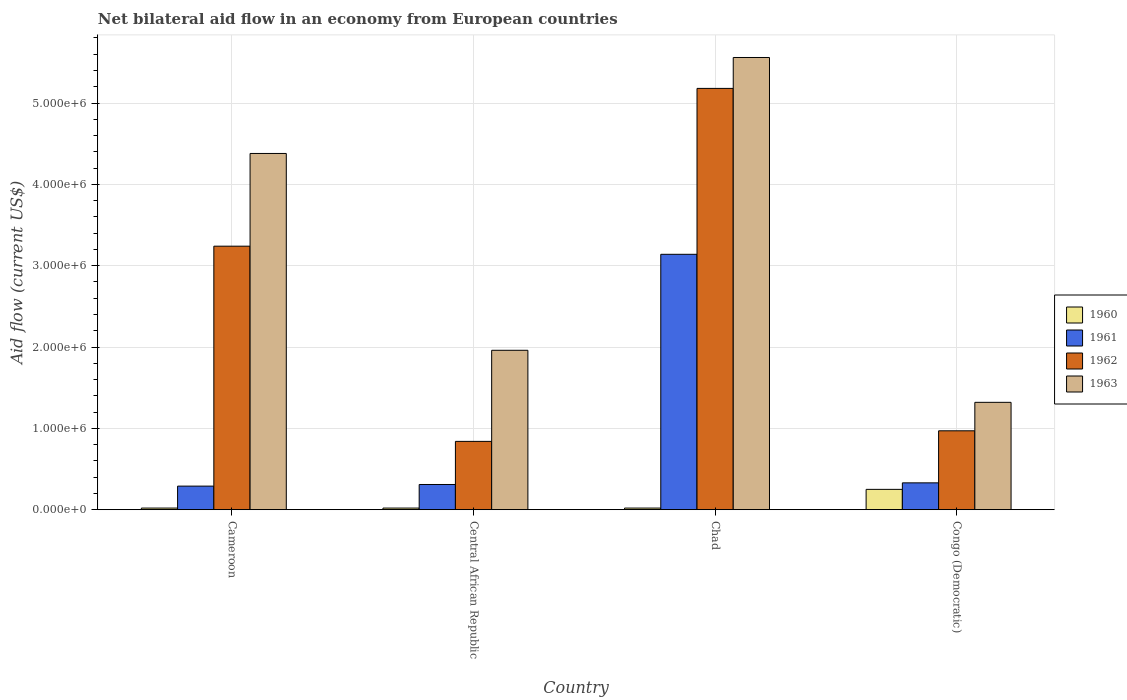How many different coloured bars are there?
Provide a succinct answer. 4. Are the number of bars per tick equal to the number of legend labels?
Give a very brief answer. Yes. How many bars are there on the 2nd tick from the left?
Your response must be concise. 4. How many bars are there on the 4th tick from the right?
Your response must be concise. 4. What is the label of the 4th group of bars from the left?
Your response must be concise. Congo (Democratic). In how many cases, is the number of bars for a given country not equal to the number of legend labels?
Ensure brevity in your answer.  0. Across all countries, what is the maximum net bilateral aid flow in 1961?
Your response must be concise. 3.14e+06. In which country was the net bilateral aid flow in 1963 maximum?
Your answer should be compact. Chad. In which country was the net bilateral aid flow in 1961 minimum?
Offer a terse response. Cameroon. What is the total net bilateral aid flow in 1961 in the graph?
Ensure brevity in your answer.  4.07e+06. What is the difference between the net bilateral aid flow in 1963 in Congo (Democratic) and the net bilateral aid flow in 1960 in Cameroon?
Your answer should be compact. 1.30e+06. What is the average net bilateral aid flow in 1961 per country?
Give a very brief answer. 1.02e+06. What is the difference between the net bilateral aid flow of/in 1962 and net bilateral aid flow of/in 1960 in Congo (Democratic)?
Provide a succinct answer. 7.20e+05. What is the ratio of the net bilateral aid flow in 1960 in Central African Republic to that in Congo (Democratic)?
Offer a terse response. 0.08. Is the difference between the net bilateral aid flow in 1962 in Cameroon and Chad greater than the difference between the net bilateral aid flow in 1960 in Cameroon and Chad?
Ensure brevity in your answer.  No. What is the difference between the highest and the second highest net bilateral aid flow in 1963?
Offer a terse response. 3.60e+06. What is the difference between the highest and the lowest net bilateral aid flow in 1961?
Offer a very short reply. 2.85e+06. In how many countries, is the net bilateral aid flow in 1963 greater than the average net bilateral aid flow in 1963 taken over all countries?
Provide a short and direct response. 2. What does the 3rd bar from the left in Central African Republic represents?
Your answer should be very brief. 1962. What does the 3rd bar from the right in Chad represents?
Provide a short and direct response. 1961. Is it the case that in every country, the sum of the net bilateral aid flow in 1963 and net bilateral aid flow in 1960 is greater than the net bilateral aid flow in 1962?
Make the answer very short. Yes. How many bars are there?
Give a very brief answer. 16. Are all the bars in the graph horizontal?
Your answer should be very brief. No. How many countries are there in the graph?
Offer a terse response. 4. Are the values on the major ticks of Y-axis written in scientific E-notation?
Ensure brevity in your answer.  Yes. Does the graph contain any zero values?
Make the answer very short. No. Where does the legend appear in the graph?
Your answer should be compact. Center right. How many legend labels are there?
Offer a very short reply. 4. What is the title of the graph?
Ensure brevity in your answer.  Net bilateral aid flow in an economy from European countries. What is the label or title of the X-axis?
Give a very brief answer. Country. What is the Aid flow (current US$) in 1962 in Cameroon?
Give a very brief answer. 3.24e+06. What is the Aid flow (current US$) of 1963 in Cameroon?
Your answer should be compact. 4.38e+06. What is the Aid flow (current US$) of 1960 in Central African Republic?
Your answer should be very brief. 2.00e+04. What is the Aid flow (current US$) of 1962 in Central African Republic?
Make the answer very short. 8.40e+05. What is the Aid flow (current US$) of 1963 in Central African Republic?
Your answer should be very brief. 1.96e+06. What is the Aid flow (current US$) in 1960 in Chad?
Keep it short and to the point. 2.00e+04. What is the Aid flow (current US$) of 1961 in Chad?
Your answer should be compact. 3.14e+06. What is the Aid flow (current US$) in 1962 in Chad?
Make the answer very short. 5.18e+06. What is the Aid flow (current US$) in 1963 in Chad?
Keep it short and to the point. 5.56e+06. What is the Aid flow (current US$) of 1962 in Congo (Democratic)?
Ensure brevity in your answer.  9.70e+05. What is the Aid flow (current US$) of 1963 in Congo (Democratic)?
Keep it short and to the point. 1.32e+06. Across all countries, what is the maximum Aid flow (current US$) in 1960?
Provide a succinct answer. 2.50e+05. Across all countries, what is the maximum Aid flow (current US$) in 1961?
Provide a succinct answer. 3.14e+06. Across all countries, what is the maximum Aid flow (current US$) of 1962?
Provide a short and direct response. 5.18e+06. Across all countries, what is the maximum Aid flow (current US$) in 1963?
Provide a succinct answer. 5.56e+06. Across all countries, what is the minimum Aid flow (current US$) in 1962?
Your response must be concise. 8.40e+05. Across all countries, what is the minimum Aid flow (current US$) of 1963?
Give a very brief answer. 1.32e+06. What is the total Aid flow (current US$) of 1961 in the graph?
Ensure brevity in your answer.  4.07e+06. What is the total Aid flow (current US$) in 1962 in the graph?
Your answer should be very brief. 1.02e+07. What is the total Aid flow (current US$) in 1963 in the graph?
Offer a very short reply. 1.32e+07. What is the difference between the Aid flow (current US$) of 1960 in Cameroon and that in Central African Republic?
Your answer should be very brief. 0. What is the difference between the Aid flow (current US$) in 1961 in Cameroon and that in Central African Republic?
Your response must be concise. -2.00e+04. What is the difference between the Aid flow (current US$) of 1962 in Cameroon and that in Central African Republic?
Provide a short and direct response. 2.40e+06. What is the difference between the Aid flow (current US$) in 1963 in Cameroon and that in Central African Republic?
Your response must be concise. 2.42e+06. What is the difference between the Aid flow (current US$) in 1960 in Cameroon and that in Chad?
Give a very brief answer. 0. What is the difference between the Aid flow (current US$) in 1961 in Cameroon and that in Chad?
Your response must be concise. -2.85e+06. What is the difference between the Aid flow (current US$) in 1962 in Cameroon and that in Chad?
Your response must be concise. -1.94e+06. What is the difference between the Aid flow (current US$) of 1963 in Cameroon and that in Chad?
Keep it short and to the point. -1.18e+06. What is the difference between the Aid flow (current US$) in 1962 in Cameroon and that in Congo (Democratic)?
Make the answer very short. 2.27e+06. What is the difference between the Aid flow (current US$) in 1963 in Cameroon and that in Congo (Democratic)?
Provide a short and direct response. 3.06e+06. What is the difference between the Aid flow (current US$) of 1960 in Central African Republic and that in Chad?
Offer a very short reply. 0. What is the difference between the Aid flow (current US$) of 1961 in Central African Republic and that in Chad?
Your answer should be compact. -2.83e+06. What is the difference between the Aid flow (current US$) of 1962 in Central African Republic and that in Chad?
Offer a very short reply. -4.34e+06. What is the difference between the Aid flow (current US$) in 1963 in Central African Republic and that in Chad?
Provide a succinct answer. -3.60e+06. What is the difference between the Aid flow (current US$) of 1963 in Central African Republic and that in Congo (Democratic)?
Ensure brevity in your answer.  6.40e+05. What is the difference between the Aid flow (current US$) of 1961 in Chad and that in Congo (Democratic)?
Offer a terse response. 2.81e+06. What is the difference between the Aid flow (current US$) in 1962 in Chad and that in Congo (Democratic)?
Keep it short and to the point. 4.21e+06. What is the difference between the Aid flow (current US$) in 1963 in Chad and that in Congo (Democratic)?
Offer a very short reply. 4.24e+06. What is the difference between the Aid flow (current US$) of 1960 in Cameroon and the Aid flow (current US$) of 1962 in Central African Republic?
Make the answer very short. -8.20e+05. What is the difference between the Aid flow (current US$) in 1960 in Cameroon and the Aid flow (current US$) in 1963 in Central African Republic?
Make the answer very short. -1.94e+06. What is the difference between the Aid flow (current US$) in 1961 in Cameroon and the Aid flow (current US$) in 1962 in Central African Republic?
Offer a terse response. -5.50e+05. What is the difference between the Aid flow (current US$) in 1961 in Cameroon and the Aid flow (current US$) in 1963 in Central African Republic?
Your answer should be compact. -1.67e+06. What is the difference between the Aid flow (current US$) of 1962 in Cameroon and the Aid flow (current US$) of 1963 in Central African Republic?
Offer a terse response. 1.28e+06. What is the difference between the Aid flow (current US$) of 1960 in Cameroon and the Aid flow (current US$) of 1961 in Chad?
Your answer should be compact. -3.12e+06. What is the difference between the Aid flow (current US$) of 1960 in Cameroon and the Aid flow (current US$) of 1962 in Chad?
Keep it short and to the point. -5.16e+06. What is the difference between the Aid flow (current US$) of 1960 in Cameroon and the Aid flow (current US$) of 1963 in Chad?
Your response must be concise. -5.54e+06. What is the difference between the Aid flow (current US$) of 1961 in Cameroon and the Aid flow (current US$) of 1962 in Chad?
Your response must be concise. -4.89e+06. What is the difference between the Aid flow (current US$) in 1961 in Cameroon and the Aid flow (current US$) in 1963 in Chad?
Give a very brief answer. -5.27e+06. What is the difference between the Aid flow (current US$) of 1962 in Cameroon and the Aid flow (current US$) of 1963 in Chad?
Ensure brevity in your answer.  -2.32e+06. What is the difference between the Aid flow (current US$) in 1960 in Cameroon and the Aid flow (current US$) in 1961 in Congo (Democratic)?
Keep it short and to the point. -3.10e+05. What is the difference between the Aid flow (current US$) of 1960 in Cameroon and the Aid flow (current US$) of 1962 in Congo (Democratic)?
Provide a short and direct response. -9.50e+05. What is the difference between the Aid flow (current US$) in 1960 in Cameroon and the Aid flow (current US$) in 1963 in Congo (Democratic)?
Give a very brief answer. -1.30e+06. What is the difference between the Aid flow (current US$) of 1961 in Cameroon and the Aid flow (current US$) of 1962 in Congo (Democratic)?
Your response must be concise. -6.80e+05. What is the difference between the Aid flow (current US$) in 1961 in Cameroon and the Aid flow (current US$) in 1963 in Congo (Democratic)?
Make the answer very short. -1.03e+06. What is the difference between the Aid flow (current US$) of 1962 in Cameroon and the Aid flow (current US$) of 1963 in Congo (Democratic)?
Keep it short and to the point. 1.92e+06. What is the difference between the Aid flow (current US$) in 1960 in Central African Republic and the Aid flow (current US$) in 1961 in Chad?
Your answer should be compact. -3.12e+06. What is the difference between the Aid flow (current US$) in 1960 in Central African Republic and the Aid flow (current US$) in 1962 in Chad?
Offer a very short reply. -5.16e+06. What is the difference between the Aid flow (current US$) in 1960 in Central African Republic and the Aid flow (current US$) in 1963 in Chad?
Provide a short and direct response. -5.54e+06. What is the difference between the Aid flow (current US$) in 1961 in Central African Republic and the Aid flow (current US$) in 1962 in Chad?
Your answer should be compact. -4.87e+06. What is the difference between the Aid flow (current US$) in 1961 in Central African Republic and the Aid flow (current US$) in 1963 in Chad?
Your answer should be very brief. -5.25e+06. What is the difference between the Aid flow (current US$) in 1962 in Central African Republic and the Aid flow (current US$) in 1963 in Chad?
Keep it short and to the point. -4.72e+06. What is the difference between the Aid flow (current US$) in 1960 in Central African Republic and the Aid flow (current US$) in 1961 in Congo (Democratic)?
Make the answer very short. -3.10e+05. What is the difference between the Aid flow (current US$) of 1960 in Central African Republic and the Aid flow (current US$) of 1962 in Congo (Democratic)?
Give a very brief answer. -9.50e+05. What is the difference between the Aid flow (current US$) in 1960 in Central African Republic and the Aid flow (current US$) in 1963 in Congo (Democratic)?
Provide a short and direct response. -1.30e+06. What is the difference between the Aid flow (current US$) in 1961 in Central African Republic and the Aid flow (current US$) in 1962 in Congo (Democratic)?
Keep it short and to the point. -6.60e+05. What is the difference between the Aid flow (current US$) of 1961 in Central African Republic and the Aid flow (current US$) of 1963 in Congo (Democratic)?
Provide a short and direct response. -1.01e+06. What is the difference between the Aid flow (current US$) of 1962 in Central African Republic and the Aid flow (current US$) of 1963 in Congo (Democratic)?
Offer a very short reply. -4.80e+05. What is the difference between the Aid flow (current US$) of 1960 in Chad and the Aid flow (current US$) of 1961 in Congo (Democratic)?
Your response must be concise. -3.10e+05. What is the difference between the Aid flow (current US$) in 1960 in Chad and the Aid flow (current US$) in 1962 in Congo (Democratic)?
Provide a short and direct response. -9.50e+05. What is the difference between the Aid flow (current US$) of 1960 in Chad and the Aid flow (current US$) of 1963 in Congo (Democratic)?
Provide a short and direct response. -1.30e+06. What is the difference between the Aid flow (current US$) in 1961 in Chad and the Aid flow (current US$) in 1962 in Congo (Democratic)?
Your response must be concise. 2.17e+06. What is the difference between the Aid flow (current US$) in 1961 in Chad and the Aid flow (current US$) in 1963 in Congo (Democratic)?
Ensure brevity in your answer.  1.82e+06. What is the difference between the Aid flow (current US$) of 1962 in Chad and the Aid flow (current US$) of 1963 in Congo (Democratic)?
Provide a succinct answer. 3.86e+06. What is the average Aid flow (current US$) in 1960 per country?
Provide a short and direct response. 7.75e+04. What is the average Aid flow (current US$) in 1961 per country?
Your response must be concise. 1.02e+06. What is the average Aid flow (current US$) of 1962 per country?
Give a very brief answer. 2.56e+06. What is the average Aid flow (current US$) of 1963 per country?
Your answer should be very brief. 3.30e+06. What is the difference between the Aid flow (current US$) of 1960 and Aid flow (current US$) of 1962 in Cameroon?
Ensure brevity in your answer.  -3.22e+06. What is the difference between the Aid flow (current US$) in 1960 and Aid flow (current US$) in 1963 in Cameroon?
Offer a very short reply. -4.36e+06. What is the difference between the Aid flow (current US$) in 1961 and Aid flow (current US$) in 1962 in Cameroon?
Give a very brief answer. -2.95e+06. What is the difference between the Aid flow (current US$) in 1961 and Aid flow (current US$) in 1963 in Cameroon?
Make the answer very short. -4.09e+06. What is the difference between the Aid flow (current US$) of 1962 and Aid flow (current US$) of 1963 in Cameroon?
Keep it short and to the point. -1.14e+06. What is the difference between the Aid flow (current US$) of 1960 and Aid flow (current US$) of 1962 in Central African Republic?
Your answer should be very brief. -8.20e+05. What is the difference between the Aid flow (current US$) of 1960 and Aid flow (current US$) of 1963 in Central African Republic?
Provide a succinct answer. -1.94e+06. What is the difference between the Aid flow (current US$) in 1961 and Aid flow (current US$) in 1962 in Central African Republic?
Your response must be concise. -5.30e+05. What is the difference between the Aid flow (current US$) in 1961 and Aid flow (current US$) in 1963 in Central African Republic?
Give a very brief answer. -1.65e+06. What is the difference between the Aid flow (current US$) of 1962 and Aid flow (current US$) of 1963 in Central African Republic?
Keep it short and to the point. -1.12e+06. What is the difference between the Aid flow (current US$) of 1960 and Aid flow (current US$) of 1961 in Chad?
Make the answer very short. -3.12e+06. What is the difference between the Aid flow (current US$) of 1960 and Aid flow (current US$) of 1962 in Chad?
Offer a very short reply. -5.16e+06. What is the difference between the Aid flow (current US$) in 1960 and Aid flow (current US$) in 1963 in Chad?
Offer a terse response. -5.54e+06. What is the difference between the Aid flow (current US$) in 1961 and Aid flow (current US$) in 1962 in Chad?
Provide a succinct answer. -2.04e+06. What is the difference between the Aid flow (current US$) in 1961 and Aid flow (current US$) in 1963 in Chad?
Offer a very short reply. -2.42e+06. What is the difference between the Aid flow (current US$) in 1962 and Aid flow (current US$) in 1963 in Chad?
Your answer should be very brief. -3.80e+05. What is the difference between the Aid flow (current US$) in 1960 and Aid flow (current US$) in 1961 in Congo (Democratic)?
Your response must be concise. -8.00e+04. What is the difference between the Aid flow (current US$) in 1960 and Aid flow (current US$) in 1962 in Congo (Democratic)?
Offer a terse response. -7.20e+05. What is the difference between the Aid flow (current US$) of 1960 and Aid flow (current US$) of 1963 in Congo (Democratic)?
Ensure brevity in your answer.  -1.07e+06. What is the difference between the Aid flow (current US$) of 1961 and Aid flow (current US$) of 1962 in Congo (Democratic)?
Provide a short and direct response. -6.40e+05. What is the difference between the Aid flow (current US$) in 1961 and Aid flow (current US$) in 1963 in Congo (Democratic)?
Provide a succinct answer. -9.90e+05. What is the difference between the Aid flow (current US$) in 1962 and Aid flow (current US$) in 1963 in Congo (Democratic)?
Your response must be concise. -3.50e+05. What is the ratio of the Aid flow (current US$) of 1960 in Cameroon to that in Central African Republic?
Your response must be concise. 1. What is the ratio of the Aid flow (current US$) in 1961 in Cameroon to that in Central African Republic?
Keep it short and to the point. 0.94. What is the ratio of the Aid flow (current US$) of 1962 in Cameroon to that in Central African Republic?
Offer a very short reply. 3.86. What is the ratio of the Aid flow (current US$) of 1963 in Cameroon to that in Central African Republic?
Keep it short and to the point. 2.23. What is the ratio of the Aid flow (current US$) in 1960 in Cameroon to that in Chad?
Provide a short and direct response. 1. What is the ratio of the Aid flow (current US$) in 1961 in Cameroon to that in Chad?
Offer a terse response. 0.09. What is the ratio of the Aid flow (current US$) in 1962 in Cameroon to that in Chad?
Offer a very short reply. 0.63. What is the ratio of the Aid flow (current US$) in 1963 in Cameroon to that in Chad?
Make the answer very short. 0.79. What is the ratio of the Aid flow (current US$) of 1961 in Cameroon to that in Congo (Democratic)?
Give a very brief answer. 0.88. What is the ratio of the Aid flow (current US$) in 1962 in Cameroon to that in Congo (Democratic)?
Keep it short and to the point. 3.34. What is the ratio of the Aid flow (current US$) of 1963 in Cameroon to that in Congo (Democratic)?
Give a very brief answer. 3.32. What is the ratio of the Aid flow (current US$) of 1960 in Central African Republic to that in Chad?
Offer a very short reply. 1. What is the ratio of the Aid flow (current US$) of 1961 in Central African Republic to that in Chad?
Your answer should be very brief. 0.1. What is the ratio of the Aid flow (current US$) in 1962 in Central African Republic to that in Chad?
Offer a very short reply. 0.16. What is the ratio of the Aid flow (current US$) of 1963 in Central African Republic to that in Chad?
Ensure brevity in your answer.  0.35. What is the ratio of the Aid flow (current US$) in 1961 in Central African Republic to that in Congo (Democratic)?
Provide a succinct answer. 0.94. What is the ratio of the Aid flow (current US$) in 1962 in Central African Republic to that in Congo (Democratic)?
Offer a terse response. 0.87. What is the ratio of the Aid flow (current US$) of 1963 in Central African Republic to that in Congo (Democratic)?
Your response must be concise. 1.48. What is the ratio of the Aid flow (current US$) in 1961 in Chad to that in Congo (Democratic)?
Keep it short and to the point. 9.52. What is the ratio of the Aid flow (current US$) in 1962 in Chad to that in Congo (Democratic)?
Keep it short and to the point. 5.34. What is the ratio of the Aid flow (current US$) of 1963 in Chad to that in Congo (Democratic)?
Provide a short and direct response. 4.21. What is the difference between the highest and the second highest Aid flow (current US$) of 1960?
Offer a terse response. 2.30e+05. What is the difference between the highest and the second highest Aid flow (current US$) in 1961?
Your answer should be very brief. 2.81e+06. What is the difference between the highest and the second highest Aid flow (current US$) in 1962?
Offer a very short reply. 1.94e+06. What is the difference between the highest and the second highest Aid flow (current US$) of 1963?
Provide a short and direct response. 1.18e+06. What is the difference between the highest and the lowest Aid flow (current US$) in 1960?
Ensure brevity in your answer.  2.30e+05. What is the difference between the highest and the lowest Aid flow (current US$) in 1961?
Your answer should be compact. 2.85e+06. What is the difference between the highest and the lowest Aid flow (current US$) of 1962?
Offer a terse response. 4.34e+06. What is the difference between the highest and the lowest Aid flow (current US$) of 1963?
Ensure brevity in your answer.  4.24e+06. 